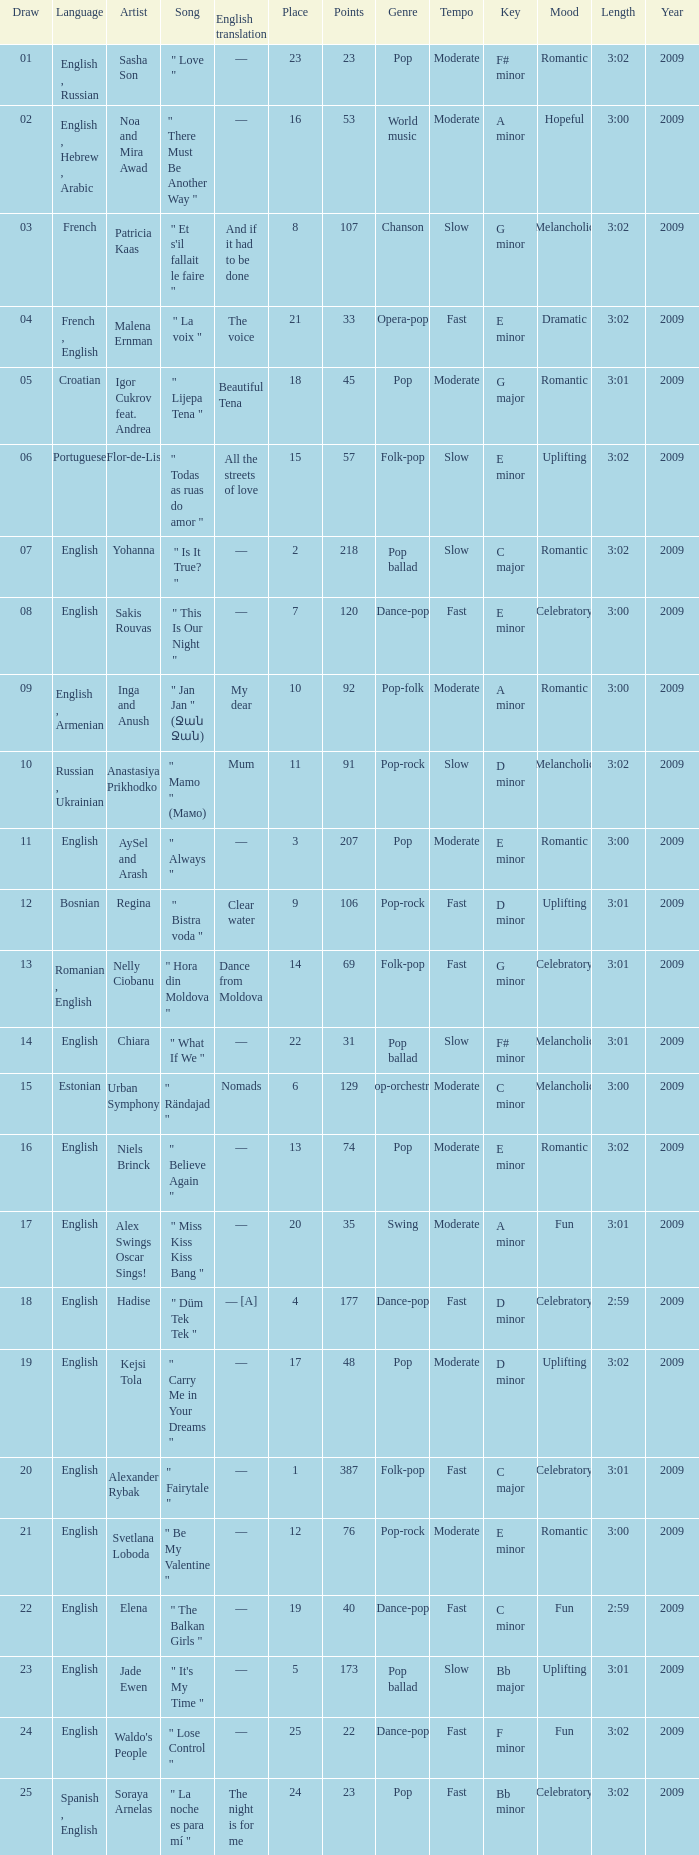What was the average place for the song that had 69 points and a draw smaller than 13? None. I'm looking to parse the entire table for insights. Could you assist me with that? {'header': ['Draw', 'Language', 'Artist', 'Song', 'English translation', 'Place', 'Points', 'Genre', 'Tempo', 'Key', 'Mood', 'Length', 'Year'], 'rows': [['01', 'English , Russian', 'Sasha Son', '" Love "', '—', '23', '23', 'Pop', 'Moderate', 'F# minor', 'Romantic', '3:02', '2009'], ['02', 'English , Hebrew , Arabic', 'Noa and Mira Awad', '" There Must Be Another Way "', '—', '16', '53', 'World music', 'Moderate', 'A minor', 'Hopeful', '3:00', '2009'], ['03', 'French', 'Patricia Kaas', '" Et s\'il fallait le faire "', 'And if it had to be done', '8', '107', 'Chanson', 'Slow', 'G minor', 'Melancholic', '3:02', '2009'], ['04', 'French , English', 'Malena Ernman', '" La voix "', 'The voice', '21', '33', 'Opera-pop', 'Fast', 'E minor', 'Dramatic', '3:02', '2009'], ['05', 'Croatian', 'Igor Cukrov feat. Andrea', '" Lijepa Tena "', 'Beautiful Tena', '18', '45', 'Pop', 'Moderate', 'G major', 'Romantic', '3:01', '2009'], ['06', 'Portuguese', 'Flor-de-Lis', '" Todas as ruas do amor "', 'All the streets of love', '15', '57', 'Folk-pop', 'Slow', 'E minor', 'Uplifting', '3:02', '2009'], ['07', 'English', 'Yohanna', '" Is It True? "', '—', '2', '218', 'Pop ballad', 'Slow', 'C major', 'Romantic', '3:02', '2009'], ['08', 'English', 'Sakis Rouvas', '" This Is Our Night "', '—', '7', '120', 'Dance-pop', 'Fast', 'E minor', 'Celebratory', '3:00', '2009'], ['09', 'English , Armenian', 'Inga and Anush', '" Jan Jan " (Ջան Ջան)', 'My dear', '10', '92', 'Pop-folk', 'Moderate', 'A minor', 'Romantic', '3:00', '2009'], ['10', 'Russian , Ukrainian', 'Anastasiya Prikhodko', '" Mamo " (Мамо)', 'Mum', '11', '91', 'Pop-rock', 'Slow', 'D minor', 'Melancholic', '3:02', '2009'], ['11', 'English', 'AySel and Arash', '" Always "', '—', '3', '207', 'Pop', 'Moderate', 'E minor', 'Romantic', '3:00', '2009'], ['12', 'Bosnian', 'Regina', '" Bistra voda "', 'Clear water', '9', '106', 'Pop-rock', 'Fast', 'D minor', 'Uplifting', '3:01', '2009'], ['13', 'Romanian , English', 'Nelly Ciobanu', '" Hora din Moldova "', 'Dance from Moldova', '14', '69', 'Folk-pop', 'Fast', 'G minor', 'Celebratory', '3:01', '2009'], ['14', 'English', 'Chiara', '" What If We "', '—', '22', '31', 'Pop ballad', 'Slow', 'F# minor', 'Melancholic', '3:01', '2009'], ['15', 'Estonian', 'Urban Symphony', '" Rändajad "', 'Nomads', '6', '129', 'Pop-orchestral', 'Moderate', 'C minor', 'Melancholic', '3:00', '2009'], ['16', 'English', 'Niels Brinck', '" Believe Again "', '—', '13', '74', 'Pop', 'Moderate', 'E minor', 'Romantic', '3:02', '2009'], ['17', 'English', 'Alex Swings Oscar Sings!', '" Miss Kiss Kiss Bang "', '—', '20', '35', 'Swing', 'Moderate', 'A minor', 'Fun', '3:01', '2009'], ['18', 'English', 'Hadise', '" Düm Tek Tek "', '— [A]', '4', '177', 'Dance-pop', 'Fast', 'D minor', 'Celebratory', '2:59', '2009'], ['19', 'English', 'Kejsi Tola', '" Carry Me in Your Dreams "', '—', '17', '48', 'Pop', 'Moderate', 'D minor', 'Uplifting', '3:02', '2009'], ['20', 'English', 'Alexander Rybak', '" Fairytale "', '—', '1', '387', 'Folk-pop', 'Fast', 'C major', 'Celebratory', '3:01', '2009'], ['21', 'English', 'Svetlana Loboda', '" Be My Valentine "', '—', '12', '76', 'Pop-rock', 'Moderate', 'E minor', 'Romantic', '3:00', '2009'], ['22', 'English', 'Elena', '" The Balkan Girls "', '—', '19', '40', 'Dance-pop', 'Fast', 'C minor', 'Fun', '2:59', '2009'], ['23', 'English', 'Jade Ewen', '" It\'s My Time "', '—', '5', '173', 'Pop ballad', 'Slow', 'Bb major', 'Uplifting', '3:01', '2009'], ['24', 'English', "Waldo's People", '" Lose Control "', '—', '25', '22', 'Dance-pop', 'Fast', 'F minor', 'Fun', '3:02', '2009'], ['25', 'Spanish , English', 'Soraya Arnelas', '" La noche es para mí "', 'The night is for me', '24', '23', 'Pop', 'Fast', 'Bb minor', 'Celebratory', '3:02', '2009']]} 